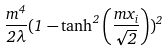<formula> <loc_0><loc_0><loc_500><loc_500>\frac { m ^ { 4 } } { 2 \lambda } ( 1 - \tanh ^ { 2 } \left ( \frac { m x _ { i } } { \sqrt { 2 } } \right ) ) ^ { 2 }</formula> 